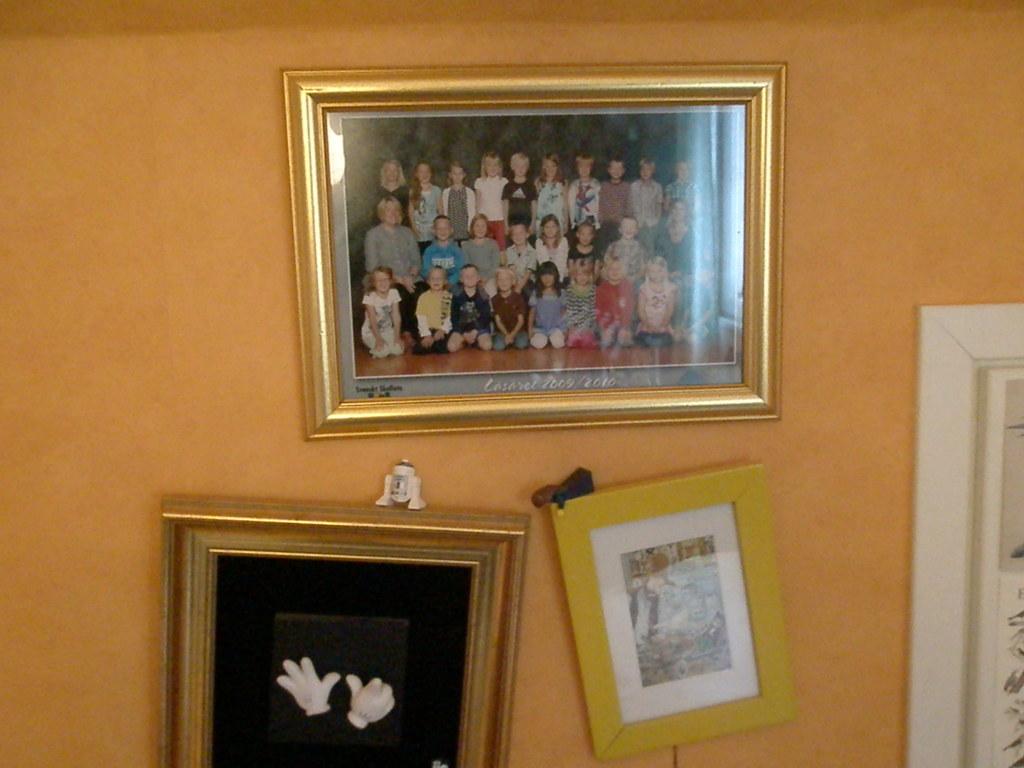What year(s) is the photo from on top?
Offer a very short reply. 2009/2010. What does the white text say in the photo of students?
Offer a very short reply. Unanswerable. 